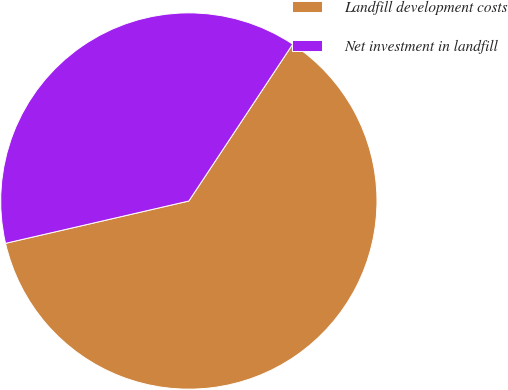Convert chart to OTSL. <chart><loc_0><loc_0><loc_500><loc_500><pie_chart><fcel>Landfill development costs<fcel>Net investment in landfill<nl><fcel>62.08%<fcel>37.92%<nl></chart> 